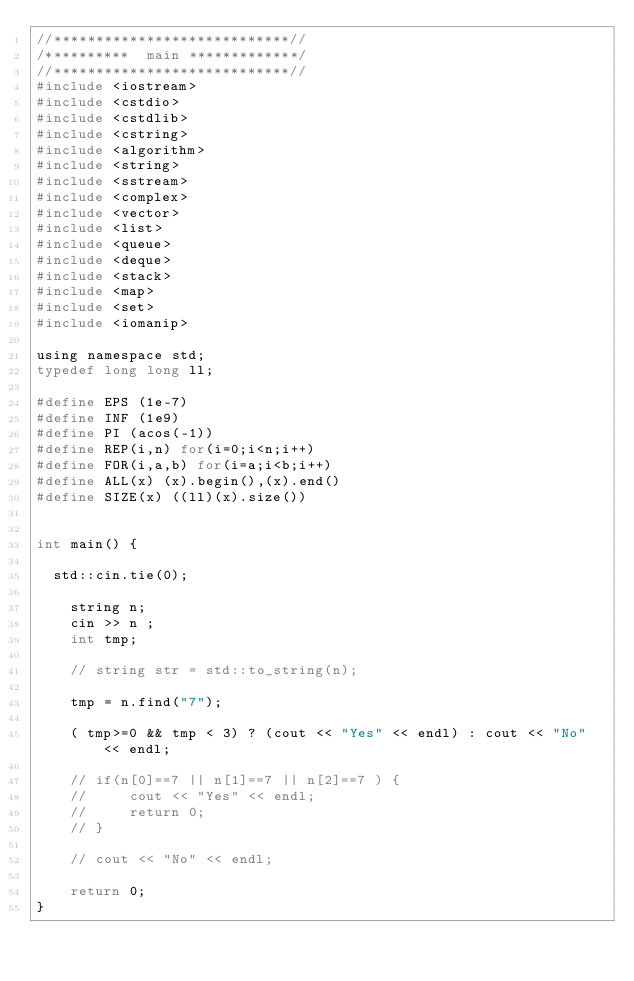Convert code to text. <code><loc_0><loc_0><loc_500><loc_500><_C_>//****************************//
/**********  main *************/
//****************************//
#include <iostream>
#include <cstdio>
#include <cstdlib>
#include <cstring>
#include <algorithm>
#include <string>
#include <sstream>
#include <complex>
#include <vector>
#include <list>
#include <queue>
#include <deque>
#include <stack>
#include <map>
#include <set>
#include <iomanip>
 
using namespace std;
typedef long long ll;
 
#define EPS (1e-7)
#define INF (1e9)
#define PI (acos(-1))
#define REP(i,n) for(i=0;i<n;i++)
#define FOR(i,a,b) for(i=a;i<b;i++)
#define ALL(x) (x).begin(),(x).end()
#define SIZE(x) ((ll)(x).size())


int main() {

	std::cin.tie(0);

    string n;
    cin >> n ;
    int tmp;

    // string str = std::to_string(n);

    tmp = n.find("7");

    ( tmp>=0 && tmp < 3) ? (cout << "Yes" << endl) : cout << "No" << endl;

    // if(n[0]==7 || n[1]==7 || n[2]==7 ) {
    //     cout << "Yes" << endl;
    //     return 0;
    // }

    // cout << "No" << endl;

    return 0;
}</code> 